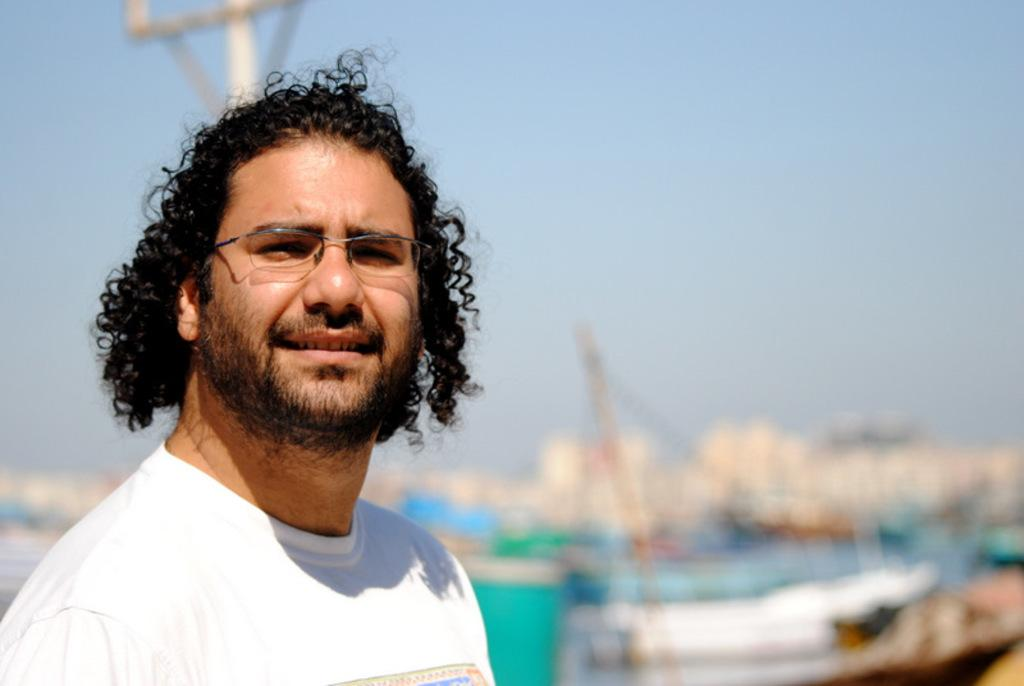Who is present in the image? There is a man in the image. What can be seen on the man's face? The man is wearing spectacles. What is the man wearing on his upper body? The man is wearing a white t-shirt. What can be seen in the background of the image? The sky is visible in the background of the image. How would you describe the background of the image? The background of the image is blurred. What type of pet is the man holding in the image? There is no pet present in the image. 